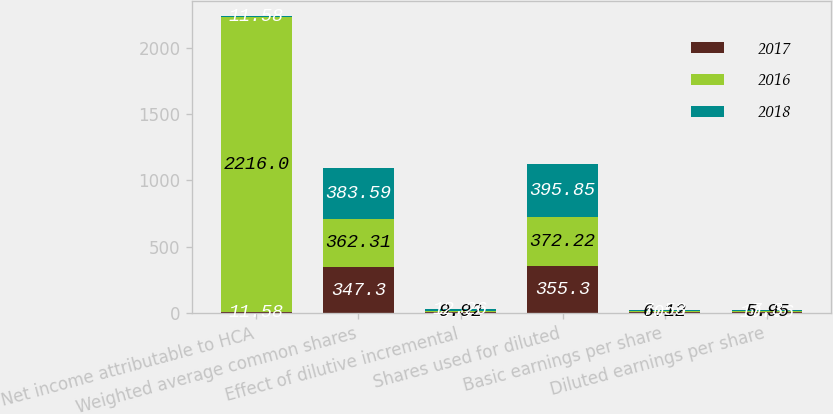Convert chart to OTSL. <chart><loc_0><loc_0><loc_500><loc_500><stacked_bar_chart><ecel><fcel>Net income attributable to HCA<fcel>Weighted average common shares<fcel>Effect of dilutive incremental<fcel>Shares used for diluted<fcel>Basic earnings per share<fcel>Diluted earnings per share<nl><fcel>2017<fcel>11.58<fcel>347.3<fcel>8.01<fcel>355.3<fcel>10.9<fcel>10.66<nl><fcel>2016<fcel>2216<fcel>362.31<fcel>9.92<fcel>372.22<fcel>6.12<fcel>5.95<nl><fcel>2018<fcel>11.58<fcel>383.59<fcel>12.26<fcel>395.85<fcel>7.53<fcel>7.3<nl></chart> 